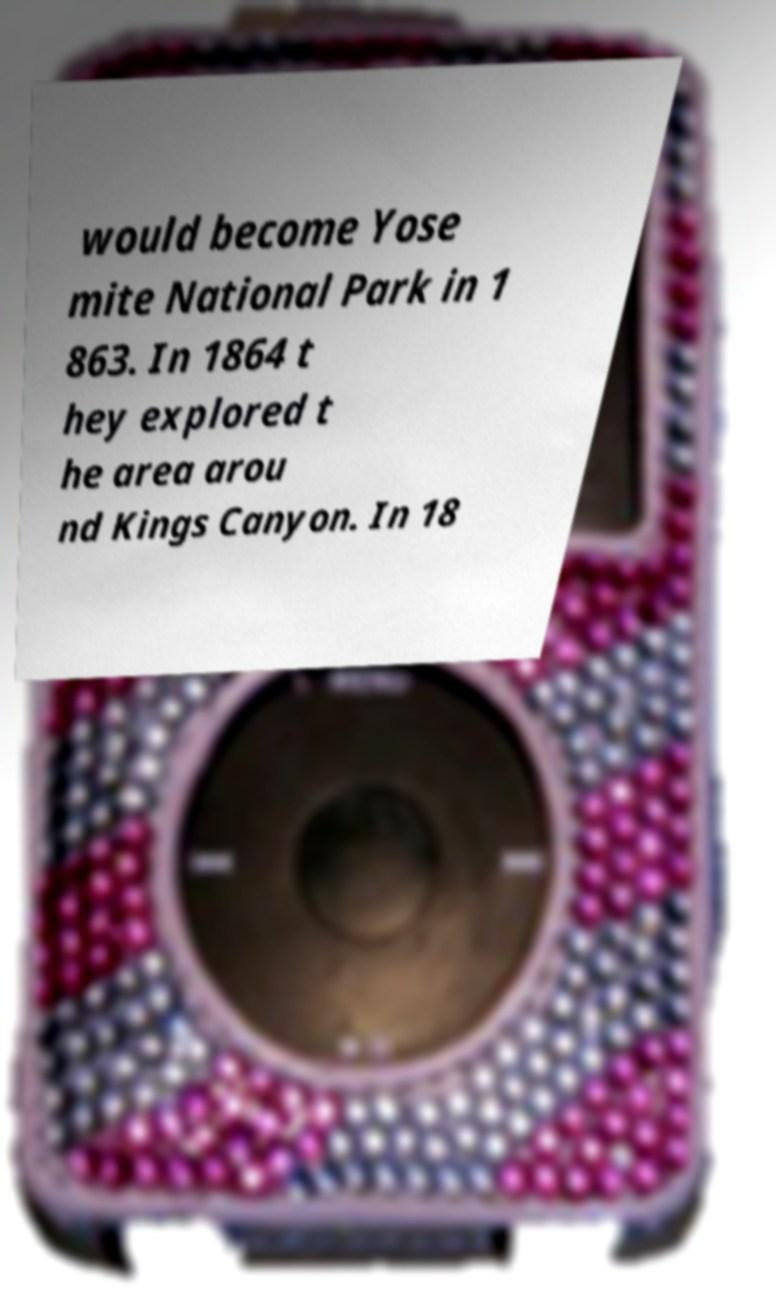For documentation purposes, I need the text within this image transcribed. Could you provide that? would become Yose mite National Park in 1 863. In 1864 t hey explored t he area arou nd Kings Canyon. In 18 